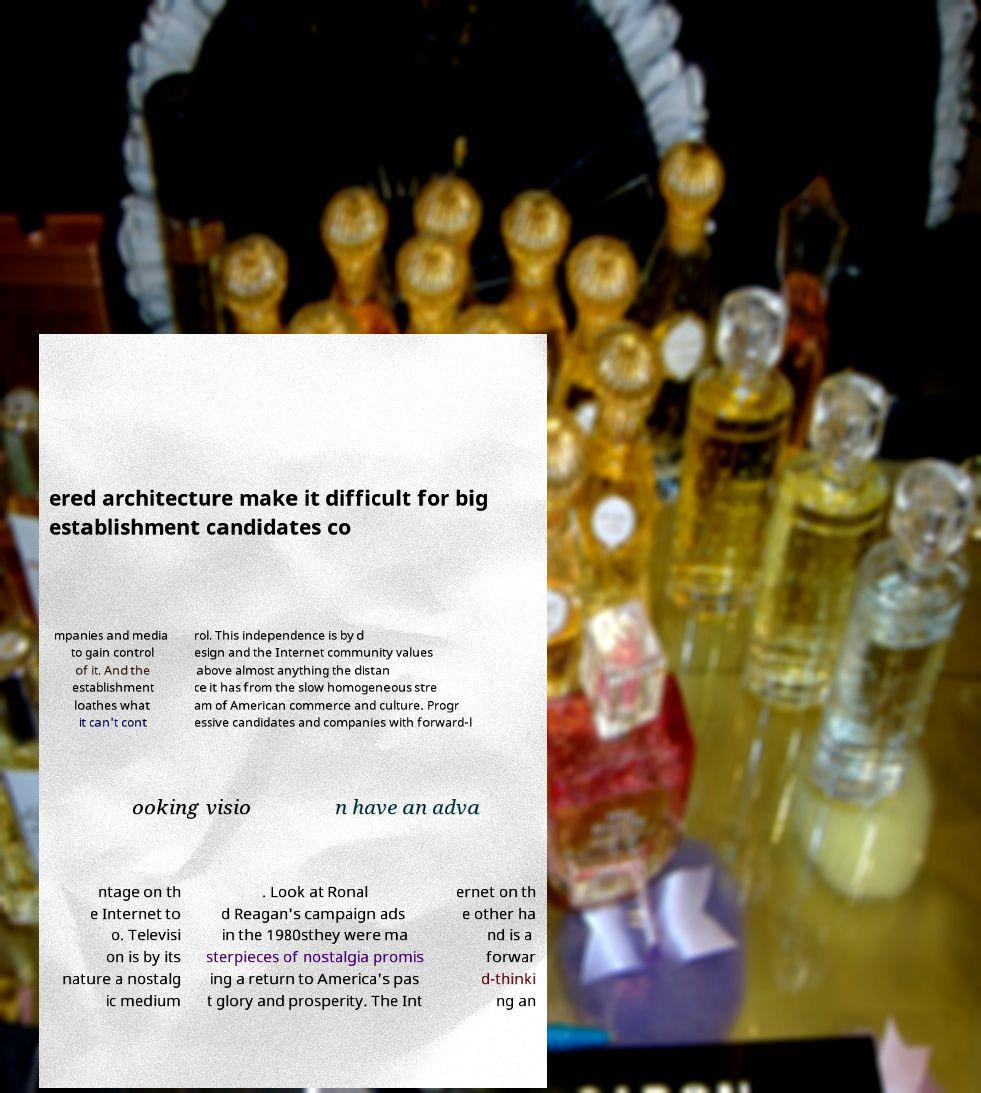Please identify and transcribe the text found in this image. ered architecture make it difficult for big establishment candidates co mpanies and media to gain control of it. And the establishment loathes what it can't cont rol. This independence is by d esign and the Internet community values above almost anything the distan ce it has from the slow homogeneous stre am of American commerce and culture. Progr essive candidates and companies with forward-l ooking visio n have an adva ntage on th e Internet to o. Televisi on is by its nature a nostalg ic medium . Look at Ronal d Reagan's campaign ads in the 1980sthey were ma sterpieces of nostalgia promis ing a return to America's pas t glory and prosperity. The Int ernet on th e other ha nd is a forwar d-thinki ng an 